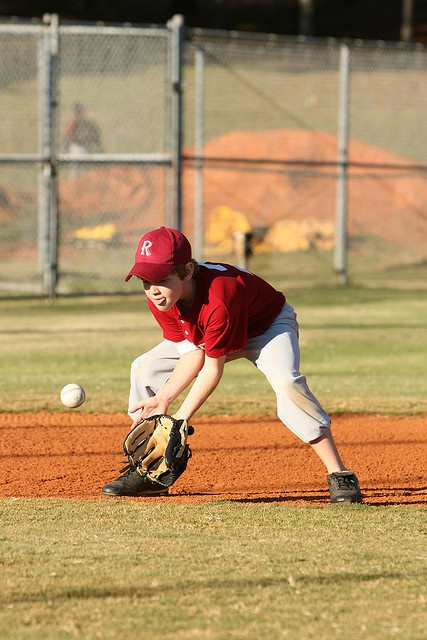Describe the objects in this image and their specific colors. I can see people in black, ivory, maroon, and tan tones, baseball glove in black, khaki, orange, and maroon tones, and sports ball in black, ivory, tan, and gray tones in this image. 